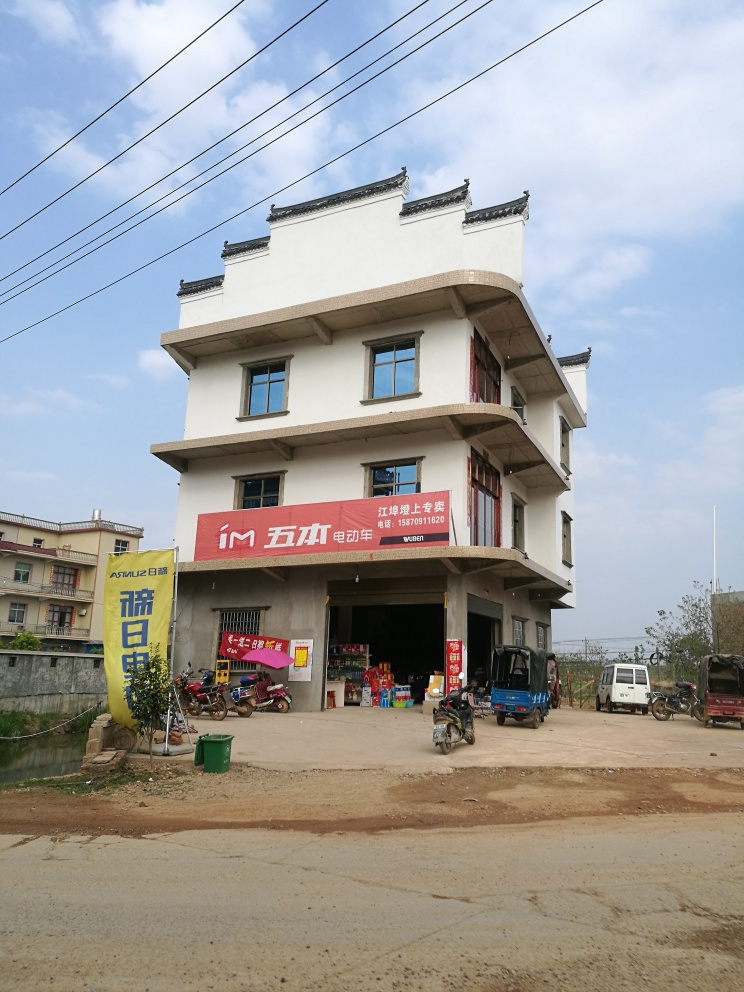What kind of business does the building seem to house, and what details support this? The building seems to house a business that provides everyday goods and possibly mechanical services. This is supported by the red shop signage, products on display at the open entrance, as well as the presence of vehicles, which could imply a service area for bikes or small trucks. Is there any indication of the location or cultural context from the image? Yes, the architectural style, as well as the textual content on the signage and banners, suggest that this image is likely taken in a Chinese-speaking region. The presence of motorcycles and the rural landscape in the background could indicate that this is in a less urbanized area of China. 